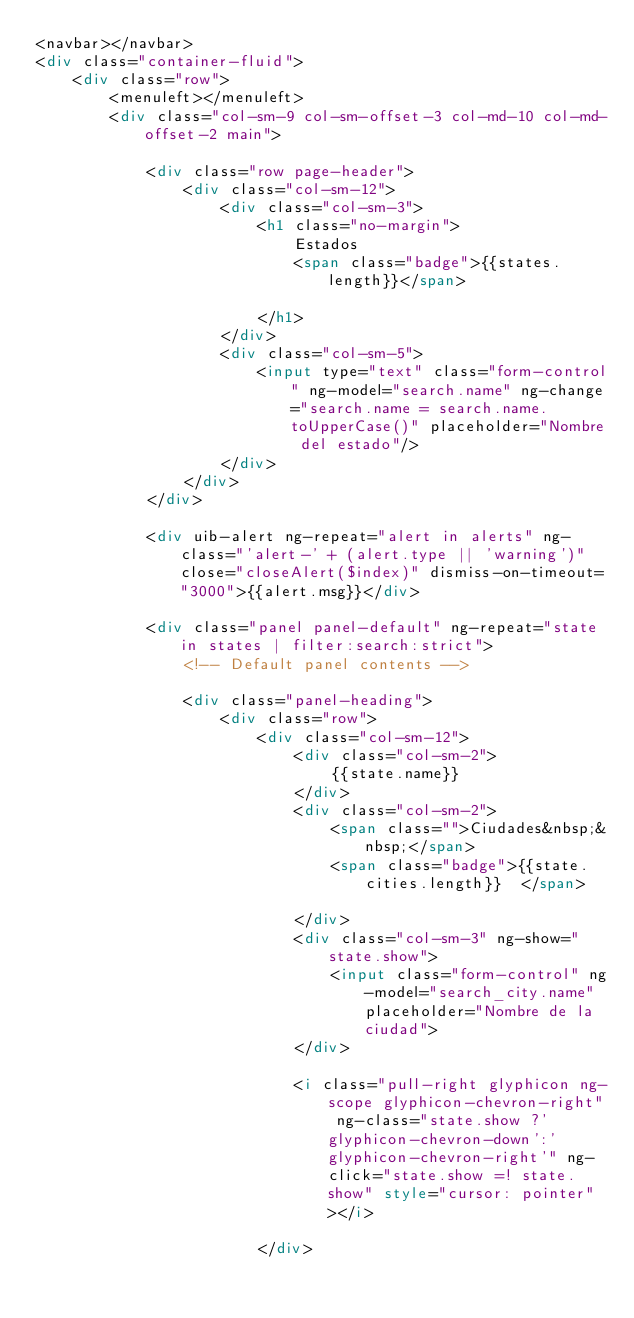Convert code to text. <code><loc_0><loc_0><loc_500><loc_500><_HTML_><navbar></navbar>
<div class="container-fluid">
	<div class="row">
		<menuleft></menuleft>
		<div class="col-sm-9 col-sm-offset-3 col-md-10 col-md-offset-2 main">
			
			<div class="row page-header">
				<div class="col-sm-12">
					<div class="col-sm-3">
						<h1 class="no-margin">
							Estados
							<span class="badge">{{states.length}}</span> 										
						</h1>					
					</div>
					<div class="col-sm-5">
						<input type="text" class="form-control" ng-model="search.name" ng-change="search.name = search.name.toUpperCase()" placeholder="Nombre del estado"/>
					</div>
				</div>
			</div>
			
			<div uib-alert ng-repeat="alert in alerts" ng-class="'alert-' + (alert.type || 'warning')" close="closeAlert($index)" dismiss-on-timeout="3000">{{alert.msg}}</div>
			
			<div class="panel panel-default" ng-repeat="state in states | filter:search:strict">
				<!-- Default panel contents -->
								
				<div class="panel-heading">
					<div class="row">
						<div class="col-sm-12">
							<div class="col-sm-2">
								{{state.name}}	
							</div>							
							<div class="col-sm-2">
								<span class="">Ciudades&nbsp;&nbsp;</span>
								<span class="badge">{{state.cities.length}}  </span>	
							</div>
							<div class="col-sm-3" ng-show="state.show">
								<input class="form-control" ng-model="search_city.name" placeholder="Nombre de la ciudad">			
							</div>									
							<i class="pull-right glyphicon ng-scope glyphicon-chevron-right" ng-class="state.show ?'glyphicon-chevron-down':'glyphicon-chevron-right'" ng-click="state.show =! state.show" style="cursor: pointer"></i>												
						</div></code> 